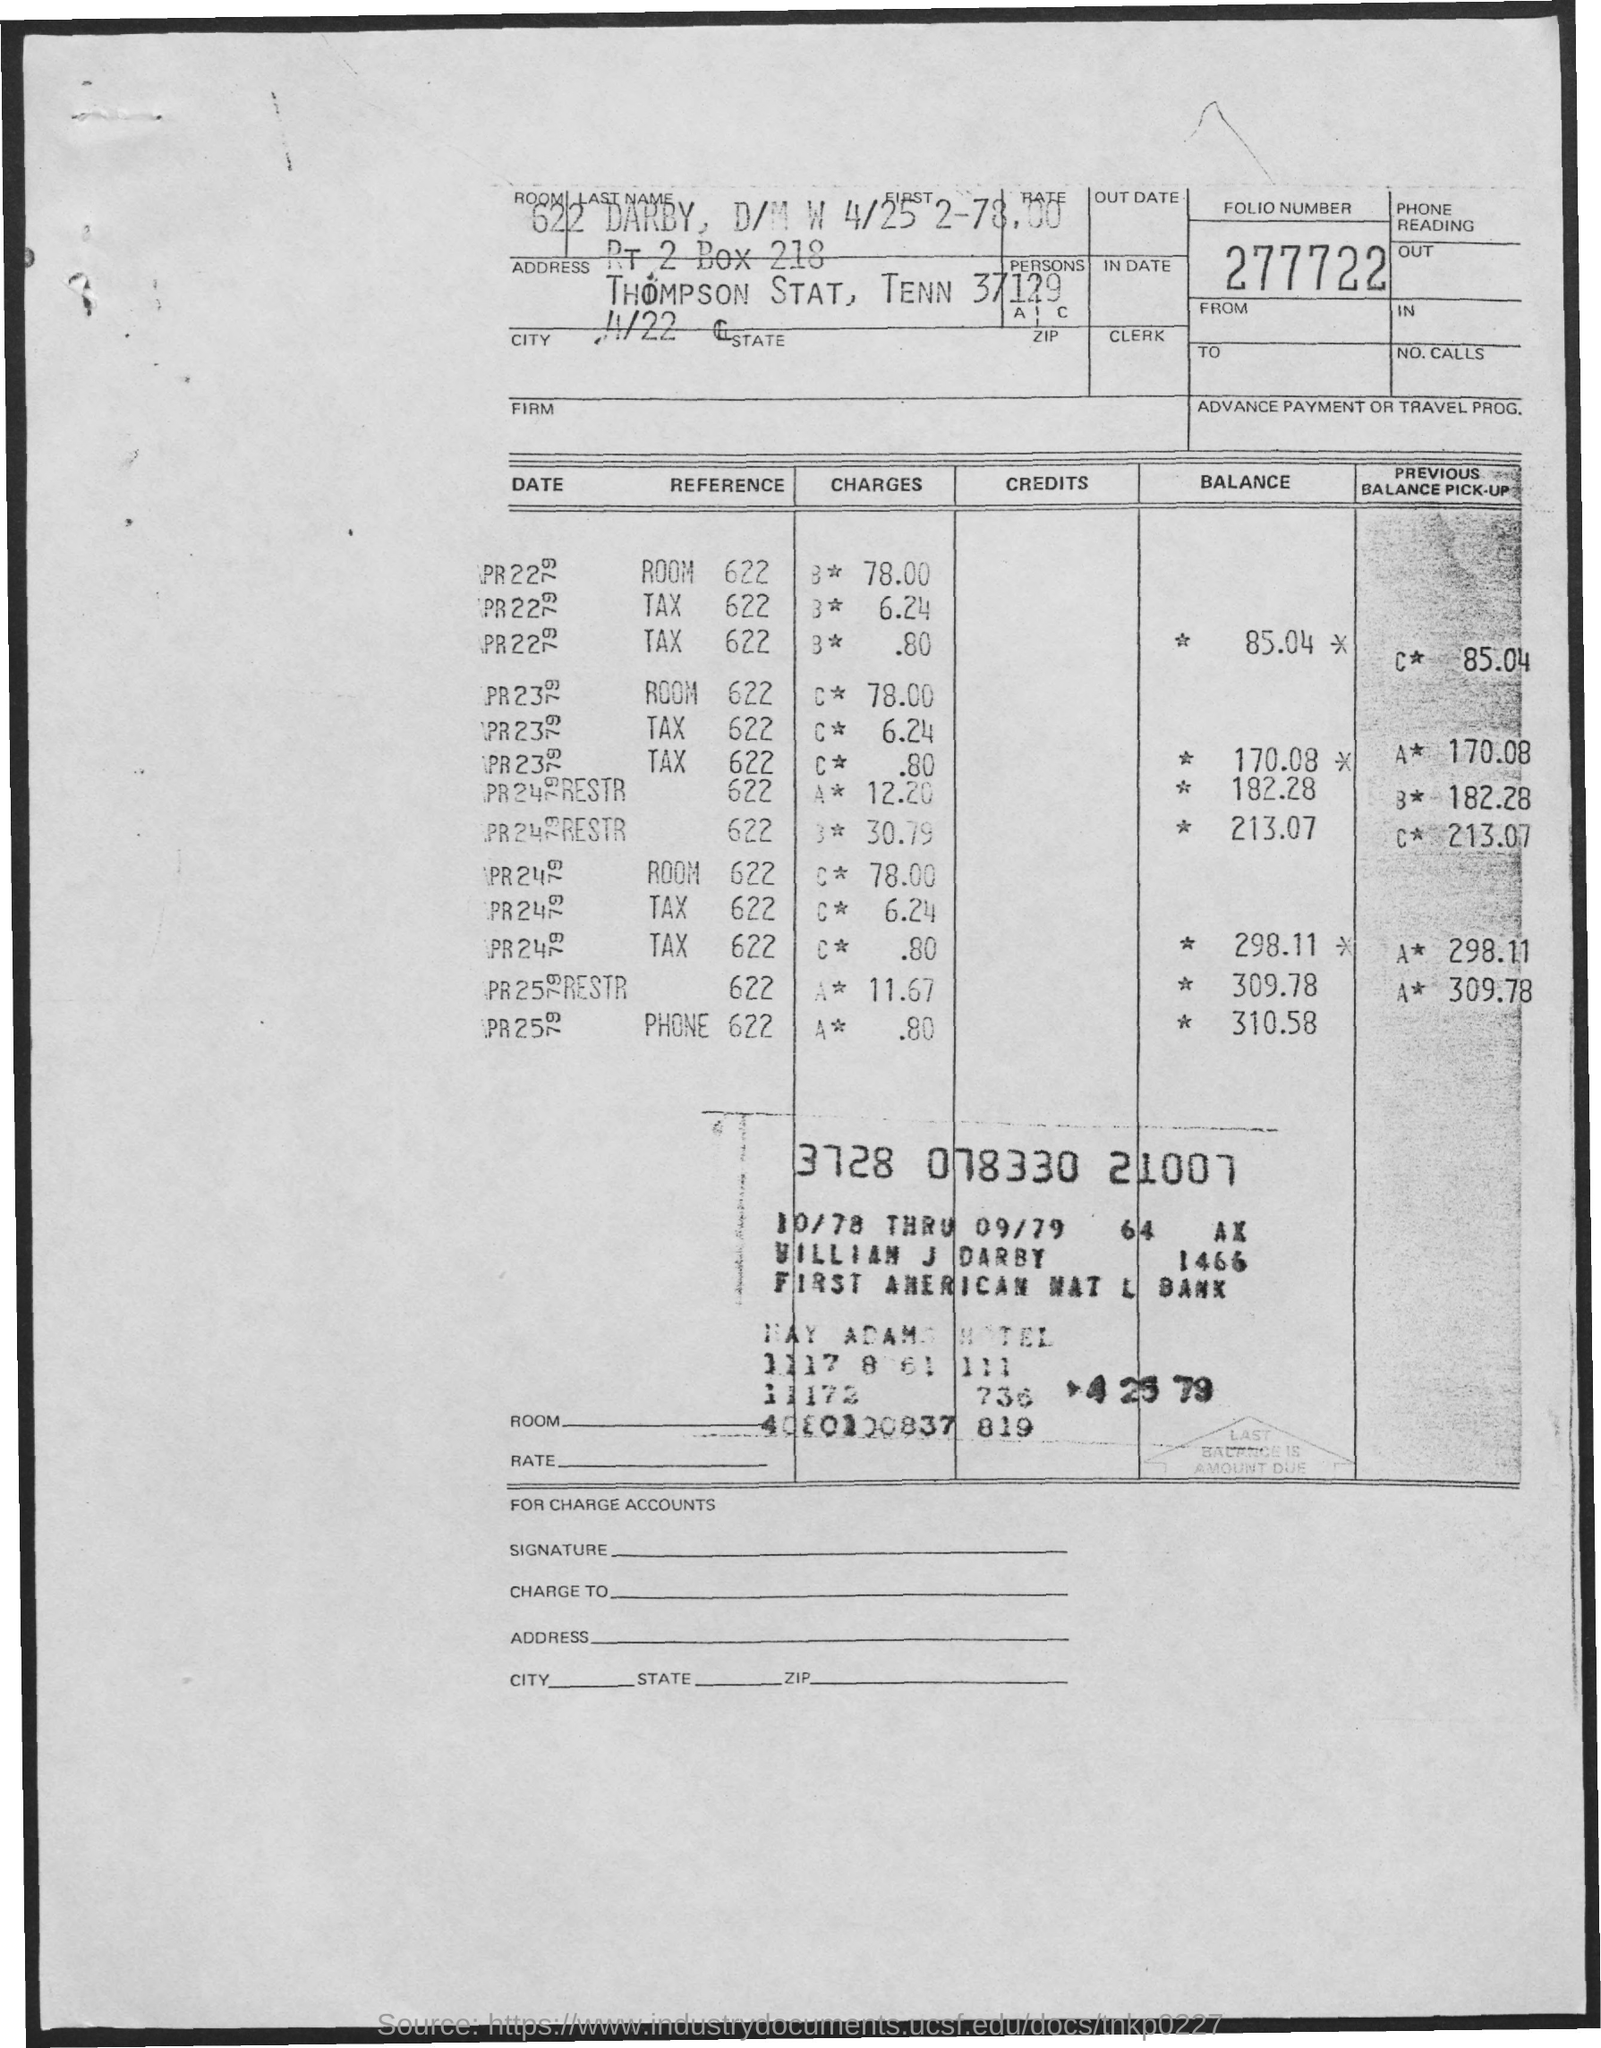Highlight a few significant elements in this photo. I would like to know the room number, specifically 622. The folio number is 277722... 